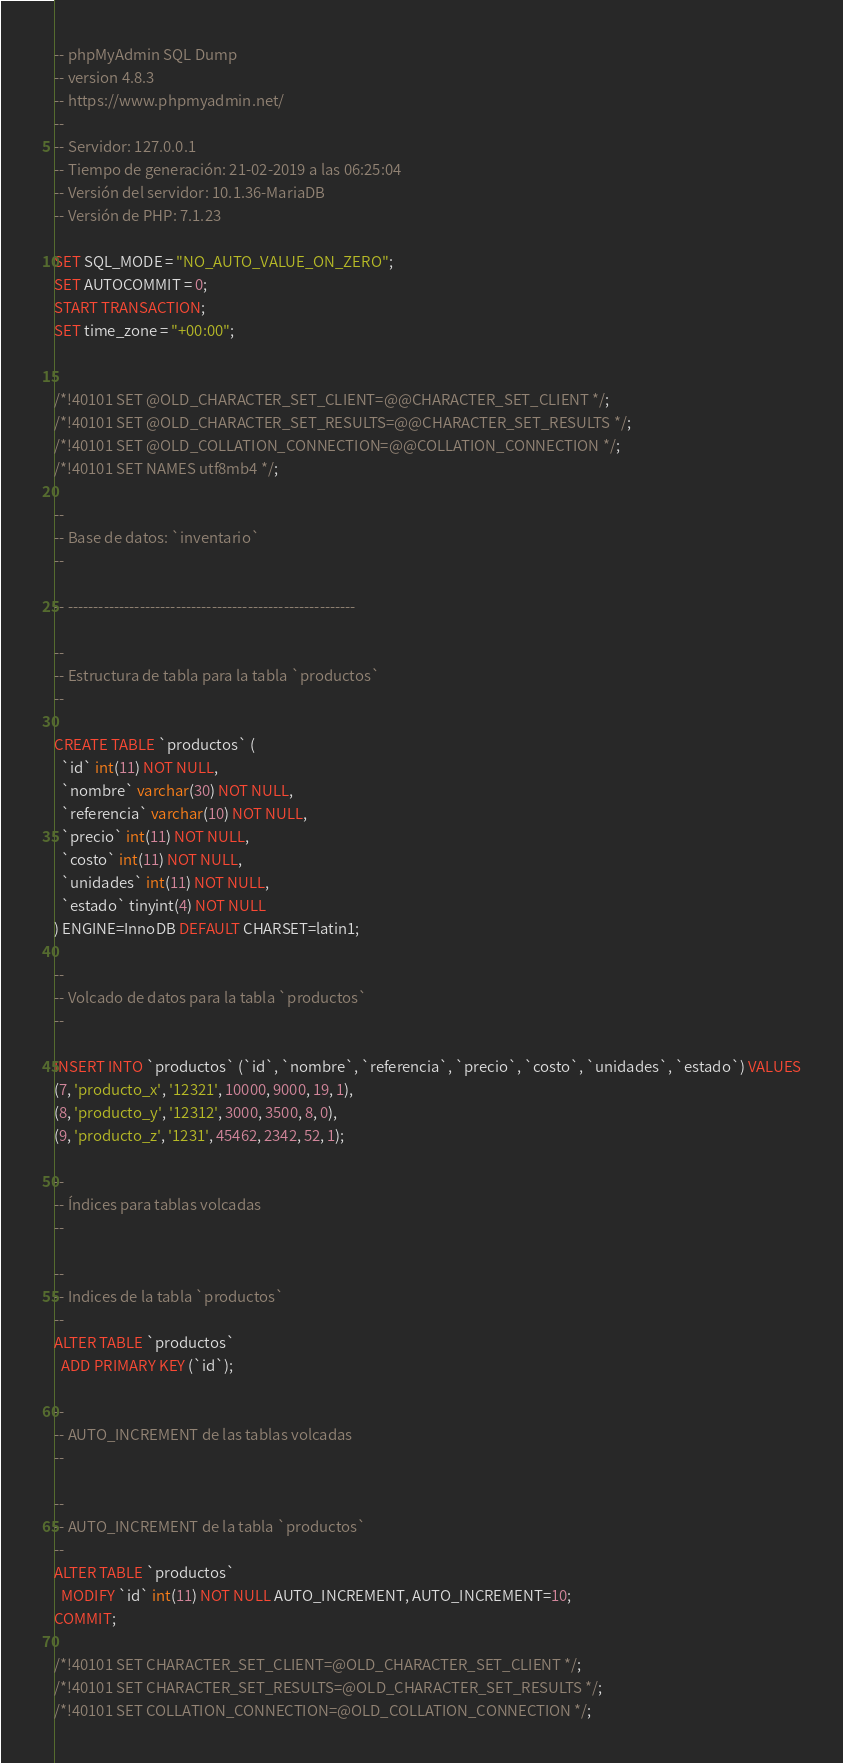Convert code to text. <code><loc_0><loc_0><loc_500><loc_500><_SQL_>-- phpMyAdmin SQL Dump
-- version 4.8.3
-- https://www.phpmyadmin.net/
--
-- Servidor: 127.0.0.1
-- Tiempo de generación: 21-02-2019 a las 06:25:04
-- Versión del servidor: 10.1.36-MariaDB
-- Versión de PHP: 7.1.23

SET SQL_MODE = "NO_AUTO_VALUE_ON_ZERO";
SET AUTOCOMMIT = 0;
START TRANSACTION;
SET time_zone = "+00:00";


/*!40101 SET @OLD_CHARACTER_SET_CLIENT=@@CHARACTER_SET_CLIENT */;
/*!40101 SET @OLD_CHARACTER_SET_RESULTS=@@CHARACTER_SET_RESULTS */;
/*!40101 SET @OLD_COLLATION_CONNECTION=@@COLLATION_CONNECTION */;
/*!40101 SET NAMES utf8mb4 */;

--
-- Base de datos: `inventario`
--

-- --------------------------------------------------------

--
-- Estructura de tabla para la tabla `productos`
--

CREATE TABLE `productos` (
  `id` int(11) NOT NULL,
  `nombre` varchar(30) NOT NULL,
  `referencia` varchar(10) NOT NULL,
  `precio` int(11) NOT NULL,
  `costo` int(11) NOT NULL,
  `unidades` int(11) NOT NULL,
  `estado` tinyint(4) NOT NULL
) ENGINE=InnoDB DEFAULT CHARSET=latin1;

--
-- Volcado de datos para la tabla `productos`
--

INSERT INTO `productos` (`id`, `nombre`, `referencia`, `precio`, `costo`, `unidades`, `estado`) VALUES
(7, 'producto_x', '12321', 10000, 9000, 19, 1),
(8, 'producto_y', '12312', 3000, 3500, 8, 0),
(9, 'producto_z', '1231', 45462, 2342, 52, 1);

--
-- Índices para tablas volcadas
--

--
-- Indices de la tabla `productos`
--
ALTER TABLE `productos`
  ADD PRIMARY KEY (`id`);

--
-- AUTO_INCREMENT de las tablas volcadas
--

--
-- AUTO_INCREMENT de la tabla `productos`
--
ALTER TABLE `productos`
  MODIFY `id` int(11) NOT NULL AUTO_INCREMENT, AUTO_INCREMENT=10;
COMMIT;

/*!40101 SET CHARACTER_SET_CLIENT=@OLD_CHARACTER_SET_CLIENT */;
/*!40101 SET CHARACTER_SET_RESULTS=@OLD_CHARACTER_SET_RESULTS */;
/*!40101 SET COLLATION_CONNECTION=@OLD_COLLATION_CONNECTION */;
</code> 